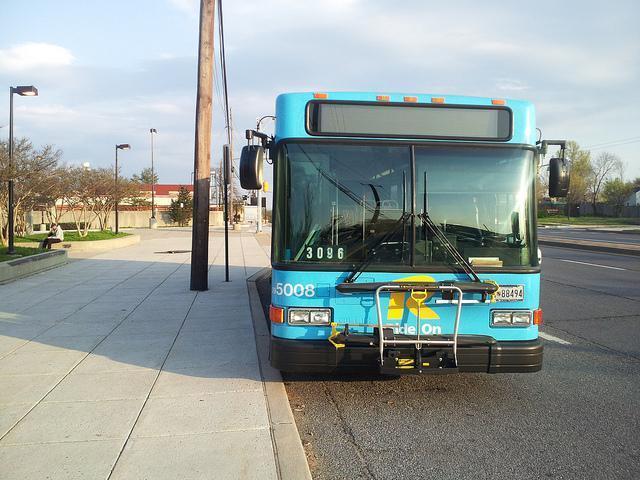How many benches are there?
Give a very brief answer. 0. 